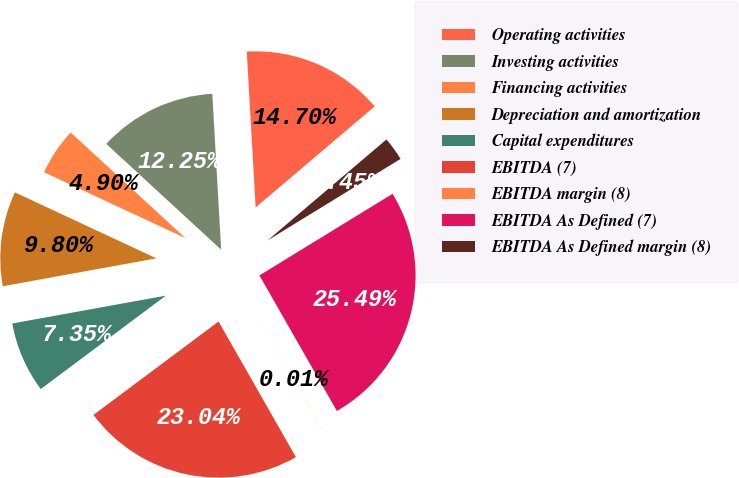<chart> <loc_0><loc_0><loc_500><loc_500><pie_chart><fcel>Operating activities<fcel>Investing activities<fcel>Financing activities<fcel>Depreciation and amortization<fcel>Capital expenditures<fcel>EBITDA (7)<fcel>EBITDA margin (8)<fcel>EBITDA As Defined (7)<fcel>EBITDA As Defined margin (8)<nl><fcel>14.7%<fcel>12.25%<fcel>4.9%<fcel>9.8%<fcel>7.35%<fcel>23.04%<fcel>0.01%<fcel>25.49%<fcel>2.45%<nl></chart> 